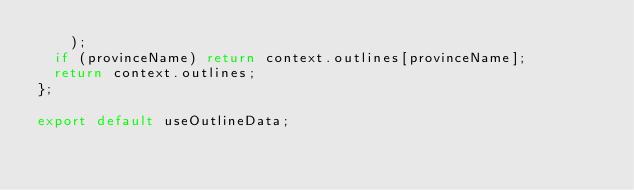Convert code to text. <code><loc_0><loc_0><loc_500><loc_500><_TypeScript_>    );
  if (provinceName) return context.outlines[provinceName];
  return context.outlines;
};

export default useOutlineData;
</code> 